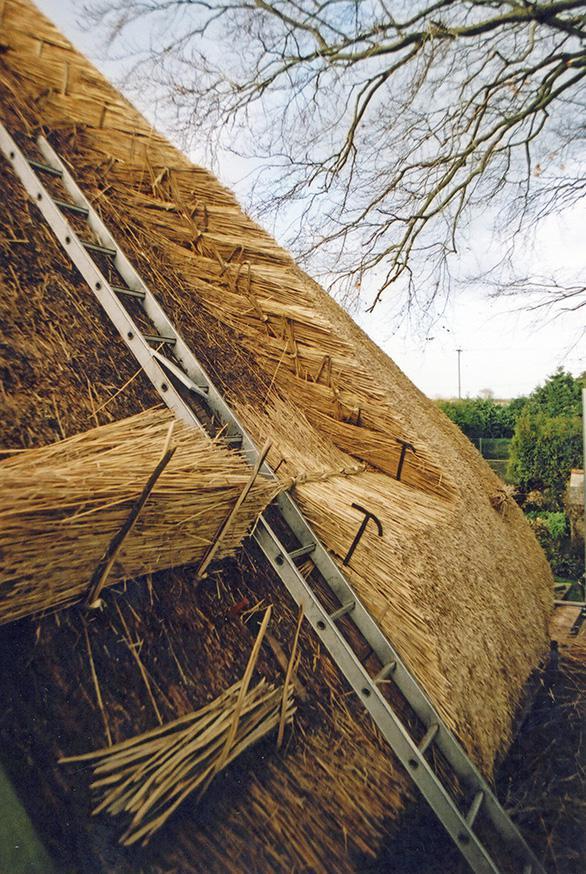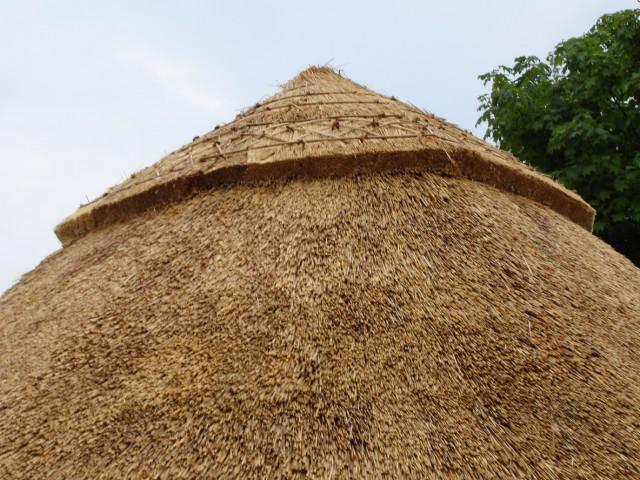The first image is the image on the left, the second image is the image on the right. Evaluate the accuracy of this statement regarding the images: "A man is standing on the roof in one of the images.". Is it true? Answer yes or no. No. The first image is the image on the left, the second image is the image on the right. Evaluate the accuracy of this statement regarding the images: "There is at least one aluminum ladder leaning against a thatched roof.". Is it true? Answer yes or no. Yes. 